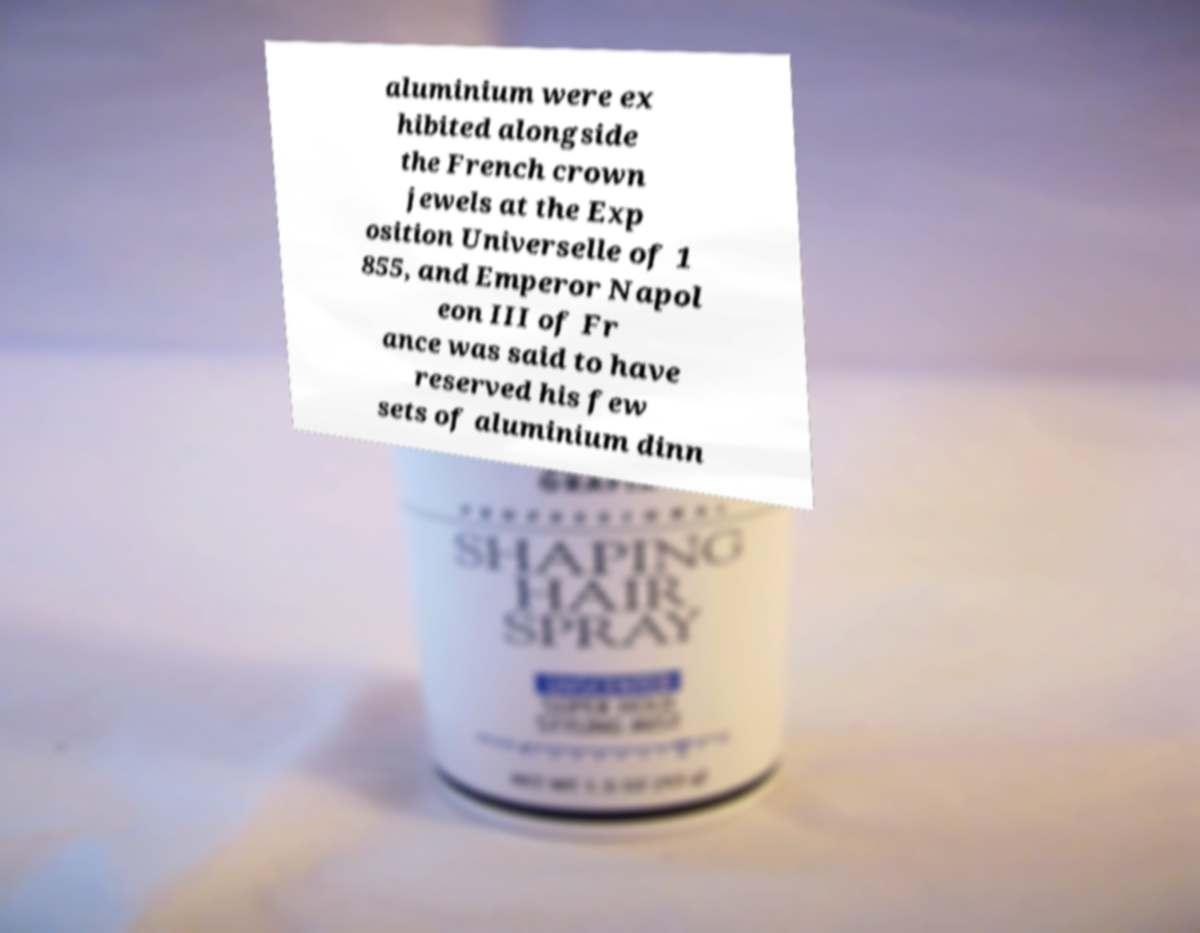There's text embedded in this image that I need extracted. Can you transcribe it verbatim? aluminium were ex hibited alongside the French crown jewels at the Exp osition Universelle of 1 855, and Emperor Napol eon III of Fr ance was said to have reserved his few sets of aluminium dinn 